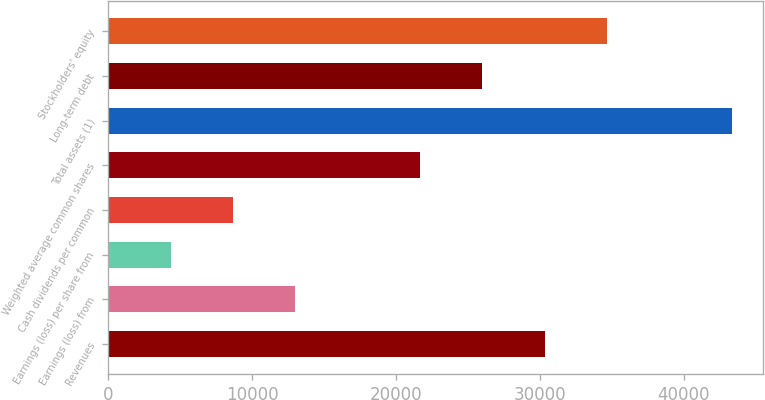<chart> <loc_0><loc_0><loc_500><loc_500><bar_chart><fcel>Revenues<fcel>Earnings (loss) from<fcel>Earnings (loss) per share from<fcel>Cash dividends per common<fcel>Weighted average common shares<fcel>Total assets (1)<fcel>Long-term debt<fcel>Stockholders' equity<nl><fcel>30328.3<fcel>12998.1<fcel>4333.02<fcel>8665.57<fcel>21663.2<fcel>43326<fcel>25995.8<fcel>34660.9<nl></chart> 